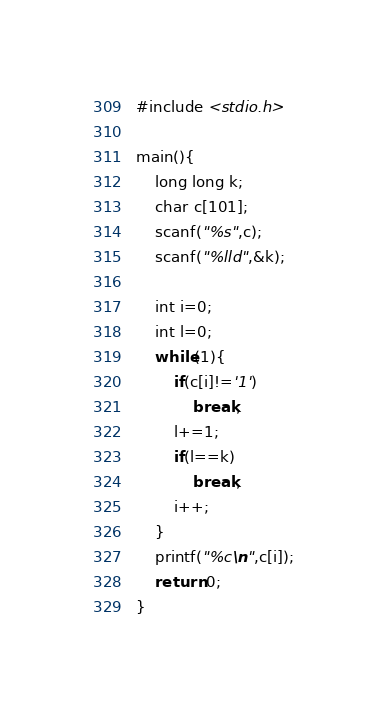Convert code to text. <code><loc_0><loc_0><loc_500><loc_500><_C_>#include <stdio.h>

main(){
    long long k;
    char c[101];
    scanf("%s",c);
    scanf("%lld",&k);

    int i=0;
    int l=0;
    while(1){
        if(c[i]!='1')
            break;
        l+=1;
        if(l==k)
            break;
        i++;
    }
    printf("%c\n",c[i]);
    return 0;
}</code> 